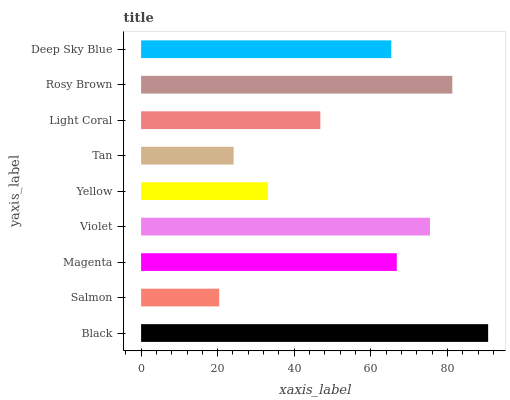Is Salmon the minimum?
Answer yes or no. Yes. Is Black the maximum?
Answer yes or no. Yes. Is Magenta the minimum?
Answer yes or no. No. Is Magenta the maximum?
Answer yes or no. No. Is Magenta greater than Salmon?
Answer yes or no. Yes. Is Salmon less than Magenta?
Answer yes or no. Yes. Is Salmon greater than Magenta?
Answer yes or no. No. Is Magenta less than Salmon?
Answer yes or no. No. Is Deep Sky Blue the high median?
Answer yes or no. Yes. Is Deep Sky Blue the low median?
Answer yes or no. Yes. Is Black the high median?
Answer yes or no. No. Is Salmon the low median?
Answer yes or no. No. 